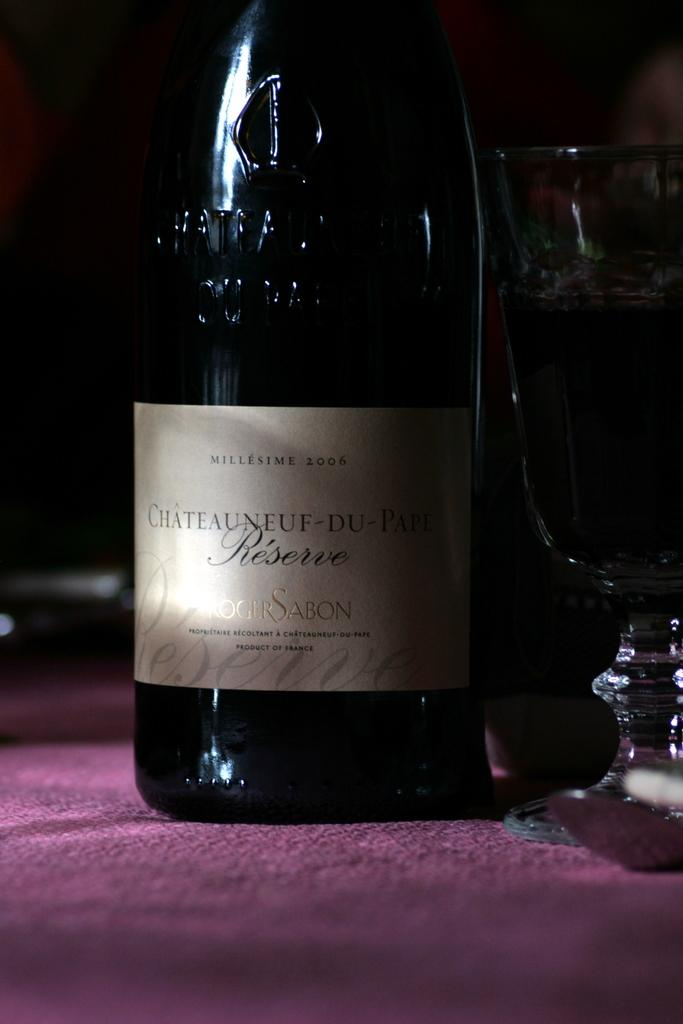<image>
Present a compact description of the photo's key features. A bottle of Chateauneuf-Du-Pape wine stands on a purple table. 